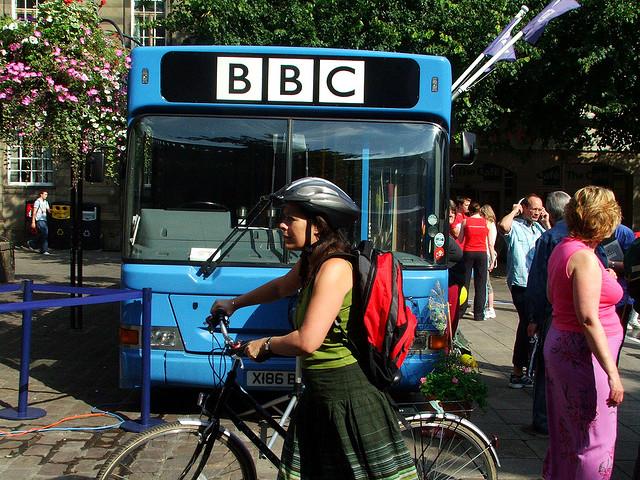What letters are on the top of the bus?
Quick response, please. Bbc. Is the bicyclist pushing the bike to the left or right?
Write a very short answer. Left. What color is the bicyclist's backpack?
Write a very short answer. Red. 